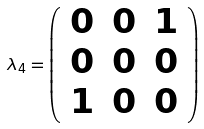<formula> <loc_0><loc_0><loc_500><loc_500>\lambda _ { 4 } = { \left ( \begin{array} { l l l } { 0 } & { 0 } & { 1 } \\ { 0 } & { 0 } & { 0 } \\ { 1 } & { 0 } & { 0 } \end{array} \right ) }</formula> 